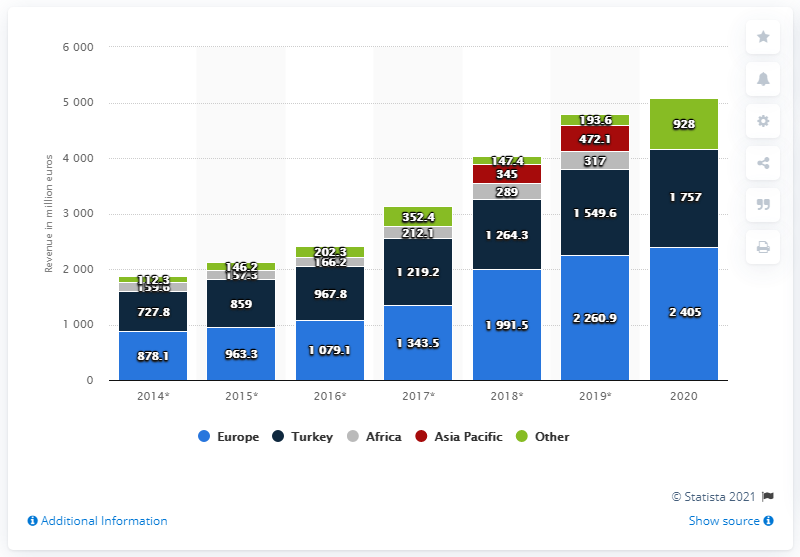Draw attention to some important aspects in this diagram. Arcelik's revenue in Turkey in 2020 was 1,757 million dollars. 